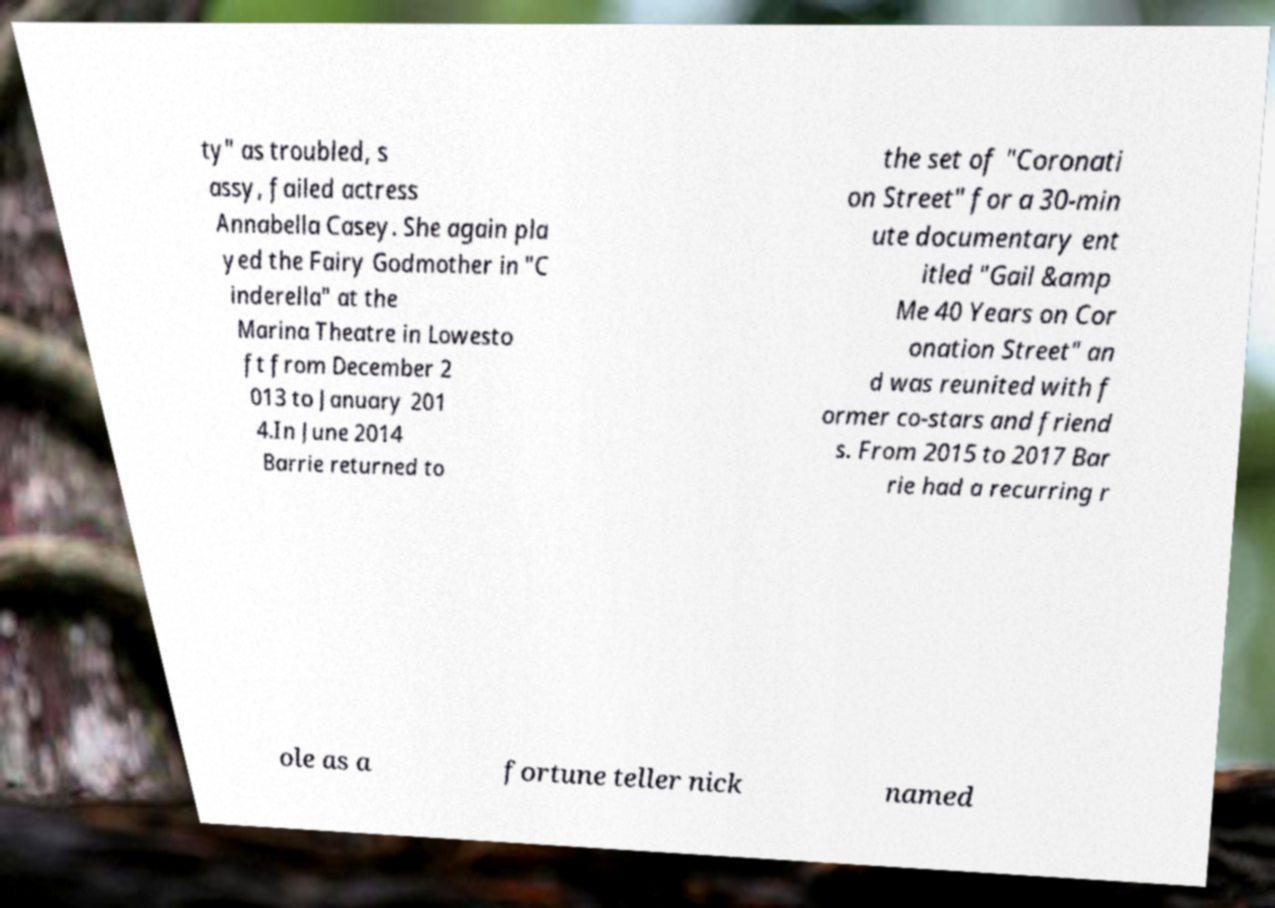There's text embedded in this image that I need extracted. Can you transcribe it verbatim? ty" as troubled, s assy, failed actress Annabella Casey. She again pla yed the Fairy Godmother in "C inderella" at the Marina Theatre in Lowesto ft from December 2 013 to January 201 4.In June 2014 Barrie returned to the set of "Coronati on Street" for a 30-min ute documentary ent itled "Gail &amp Me 40 Years on Cor onation Street" an d was reunited with f ormer co-stars and friend s. From 2015 to 2017 Bar rie had a recurring r ole as a fortune teller nick named 